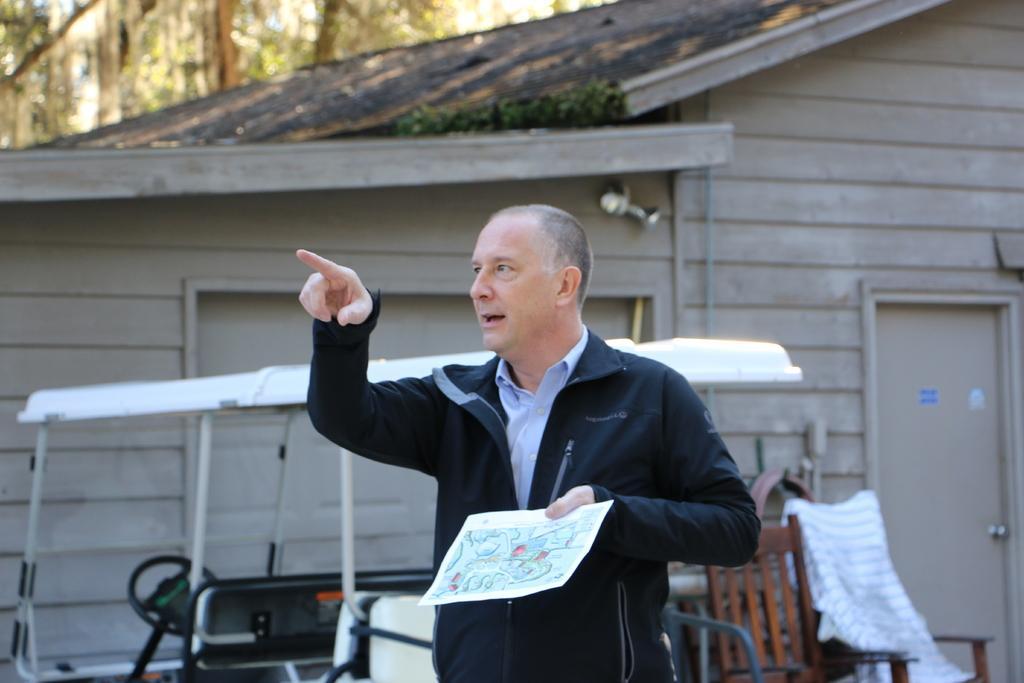How would you summarize this image in a sentence or two? In this image there is a person standing and holding a paper, and there is a vehicle, chairs,house , shutter, door , and in the background there are trees. 